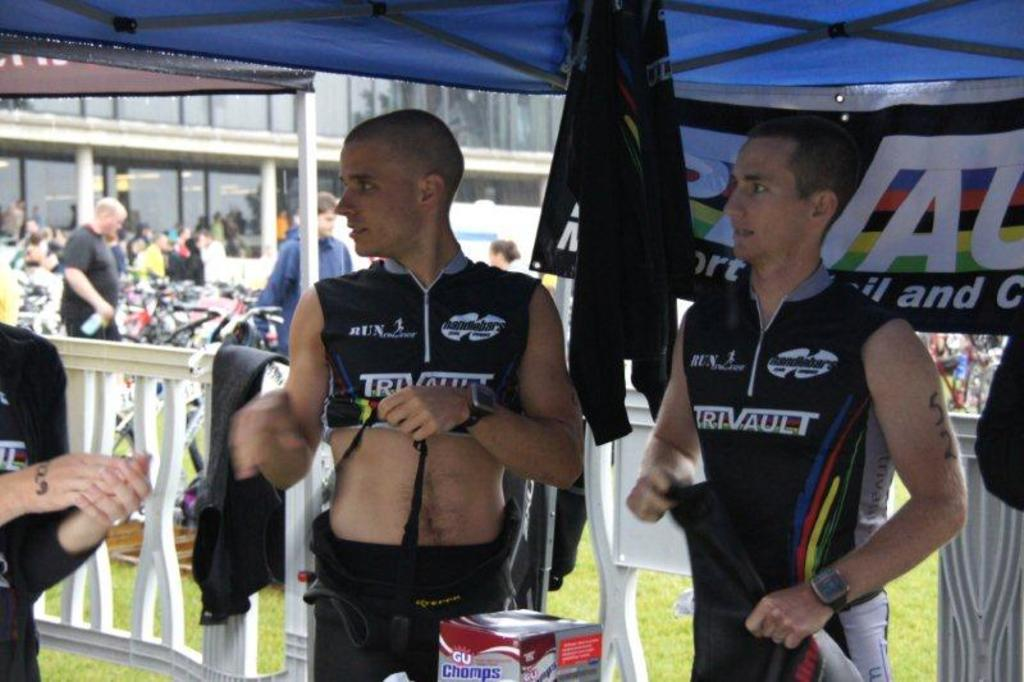<image>
Give a short and clear explanation of the subsequent image. two guys wearing truvault jerseys under a blue canopy 